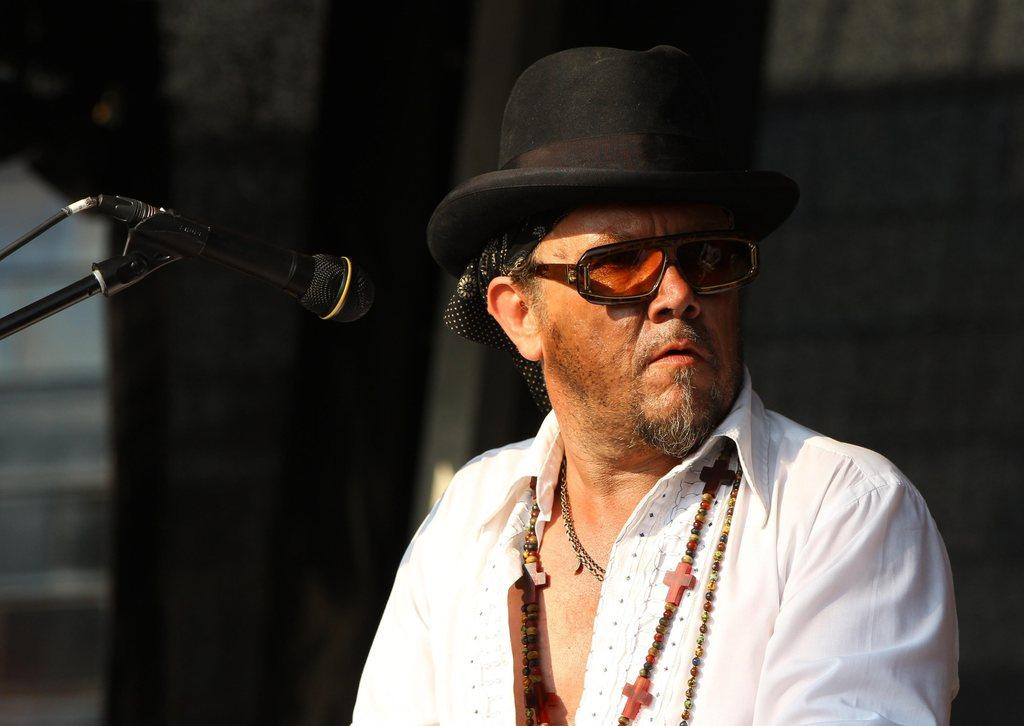Who is the main subject in the image? There is a man in the center of the image. What accessories is the man wearing? The man is wearing glasses and a hat. What object is present in the image that is typically used for amplifying sound? There is a microphone (mic) in the image. What can be seen in the background of the image? There is a wall in the background of the image. What type of soda is the man drinking in the image? There is no soda present in the image; the man is not holding or drinking any beverage. What is the weather like in the image? The provided facts do not mention any information about the weather, so it cannot be determined from the image. 